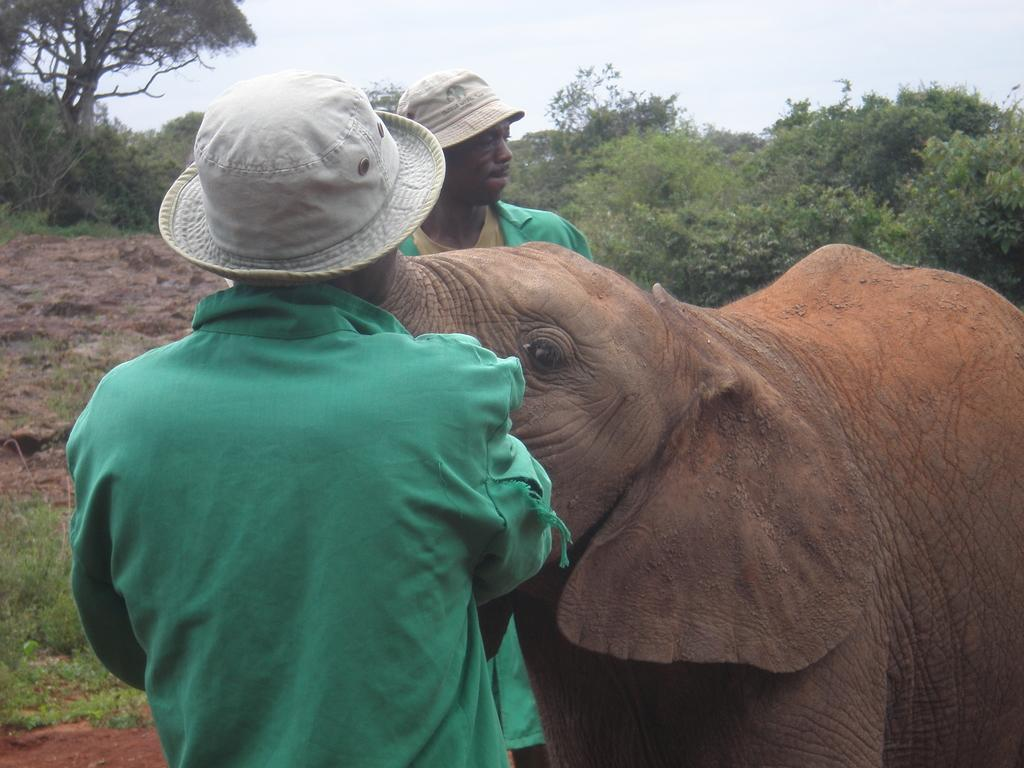How many people are in the image? There are two people in the image. What are the people wearing on their heads? The people are wearing hats. What animal is beside the people? There is an elephant beside the people. What type of vegetation can be seen in the image? There are trees and plants in the image. Can you tell me how the elephant is helping with the yard work in the image? There is no yard work being done in the image, and the elephant is not performing any tasks related to yard work. 